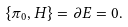<formula> <loc_0><loc_0><loc_500><loc_500>\{ \pi _ { 0 } , H \} = \partial E = 0 .</formula> 